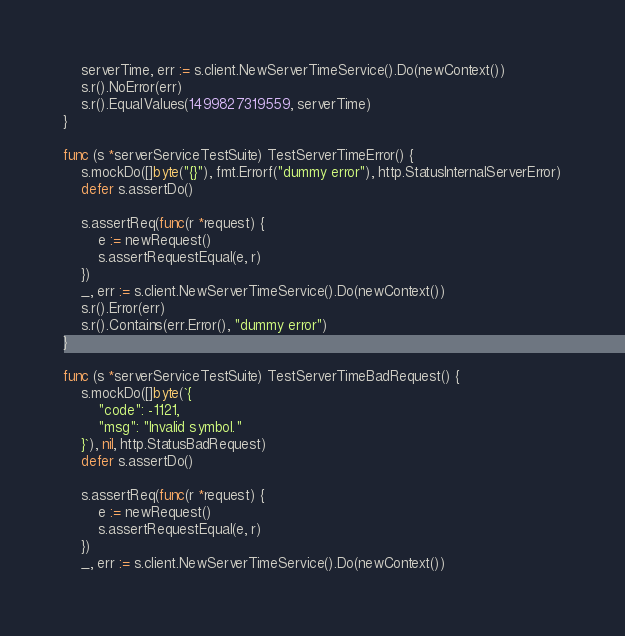<code> <loc_0><loc_0><loc_500><loc_500><_Go_>
	serverTime, err := s.client.NewServerTimeService().Do(newContext())
	s.r().NoError(err)
	s.r().EqualValues(1499827319559, serverTime)
}

func (s *serverServiceTestSuite) TestServerTimeError() {
	s.mockDo([]byte("{}"), fmt.Errorf("dummy error"), http.StatusInternalServerError)
	defer s.assertDo()

	s.assertReq(func(r *request) {
		e := newRequest()
		s.assertRequestEqual(e, r)
	})
	_, err := s.client.NewServerTimeService().Do(newContext())
	s.r().Error(err)
	s.r().Contains(err.Error(), "dummy error")
}

func (s *serverServiceTestSuite) TestServerTimeBadRequest() {
	s.mockDo([]byte(`{
        "code": -1121,
        "msg": "Invalid symbol."
    }`), nil, http.StatusBadRequest)
	defer s.assertDo()

	s.assertReq(func(r *request) {
		e := newRequest()
		s.assertRequestEqual(e, r)
	})
	_, err := s.client.NewServerTimeService().Do(newContext())</code> 